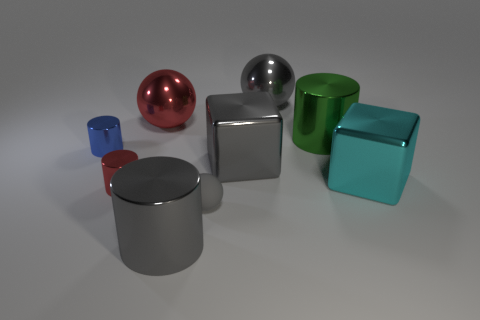What number of shiny things are on the left side of the large gray cylinder and to the right of the red cylinder?
Make the answer very short. 1. Are there fewer rubber objects that are left of the red metallic cylinder than gray rubber spheres that are in front of the large gray metal block?
Provide a succinct answer. Yes. Is the shape of the large red metallic object the same as the small gray rubber thing?
Provide a short and direct response. Yes. How many other things are there of the same size as the red metallic ball?
Your answer should be compact. 5. How many objects are either gray metal objects in front of the small gray thing or blue shiny cylinders to the left of the small matte sphere?
Your answer should be compact. 2. How many other big objects have the same shape as the cyan object?
Your response must be concise. 1. The gray object that is in front of the large cyan shiny block and right of the big gray metallic cylinder is made of what material?
Ensure brevity in your answer.  Rubber. There is a red ball; how many things are to the right of it?
Your answer should be compact. 6. What number of gray metal things are there?
Provide a short and direct response. 3. Does the green object have the same size as the blue object?
Offer a very short reply. No. 